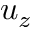<formula> <loc_0><loc_0><loc_500><loc_500>u _ { z }</formula> 